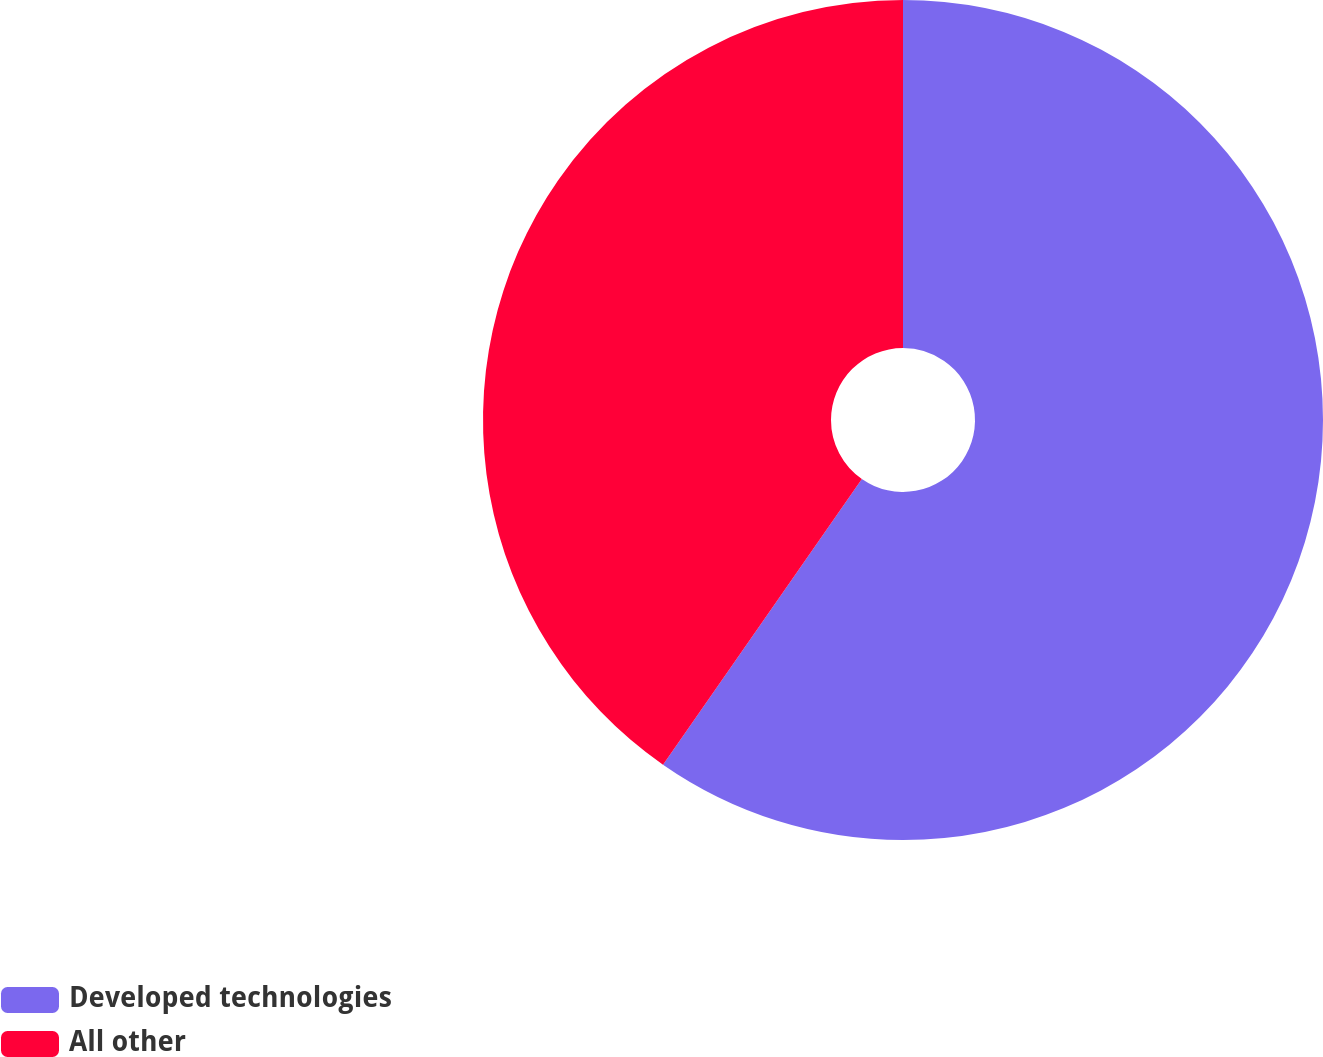Convert chart to OTSL. <chart><loc_0><loc_0><loc_500><loc_500><pie_chart><fcel>Developed technologies<fcel>All other<nl><fcel>59.68%<fcel>40.32%<nl></chart> 